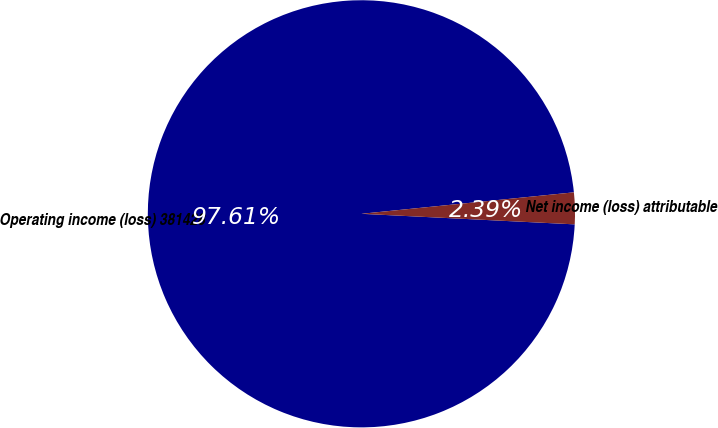Convert chart. <chart><loc_0><loc_0><loc_500><loc_500><pie_chart><fcel>Operating income (loss) 381428<fcel>Net income (loss) attributable<nl><fcel>97.61%<fcel>2.39%<nl></chart> 